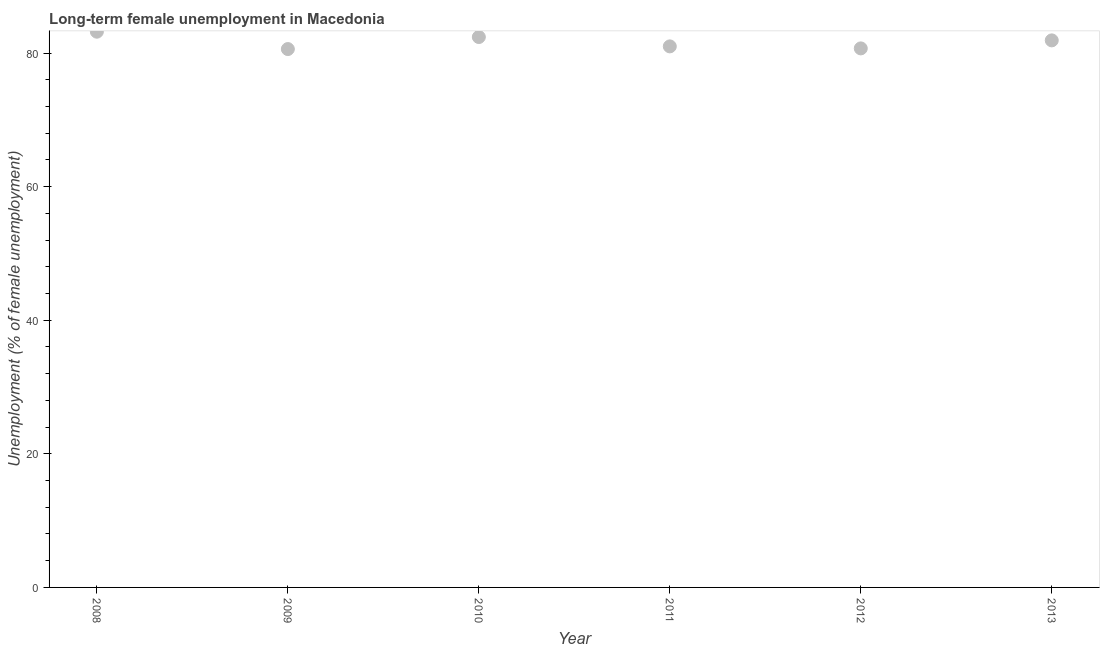What is the long-term female unemployment in 2013?
Ensure brevity in your answer.  81.9. Across all years, what is the maximum long-term female unemployment?
Your answer should be compact. 83.2. Across all years, what is the minimum long-term female unemployment?
Keep it short and to the point. 80.6. In which year was the long-term female unemployment maximum?
Give a very brief answer. 2008. What is the sum of the long-term female unemployment?
Ensure brevity in your answer.  489.8. What is the difference between the long-term female unemployment in 2008 and 2011?
Your answer should be compact. 2.2. What is the average long-term female unemployment per year?
Offer a very short reply. 81.63. What is the median long-term female unemployment?
Offer a terse response. 81.45. In how many years, is the long-term female unemployment greater than 40 %?
Provide a succinct answer. 6. What is the ratio of the long-term female unemployment in 2010 to that in 2012?
Provide a succinct answer. 1.02. Is the long-term female unemployment in 2008 less than that in 2009?
Provide a short and direct response. No. Is the difference between the long-term female unemployment in 2008 and 2010 greater than the difference between any two years?
Your answer should be very brief. No. What is the difference between the highest and the second highest long-term female unemployment?
Provide a short and direct response. 0.8. Is the sum of the long-term female unemployment in 2009 and 2011 greater than the maximum long-term female unemployment across all years?
Your answer should be very brief. Yes. What is the difference between the highest and the lowest long-term female unemployment?
Offer a terse response. 2.6. In how many years, is the long-term female unemployment greater than the average long-term female unemployment taken over all years?
Your answer should be compact. 3. Does the long-term female unemployment monotonically increase over the years?
Your response must be concise. No. How many dotlines are there?
Provide a short and direct response. 1. How many years are there in the graph?
Make the answer very short. 6. What is the difference between two consecutive major ticks on the Y-axis?
Your answer should be very brief. 20. Are the values on the major ticks of Y-axis written in scientific E-notation?
Keep it short and to the point. No. What is the title of the graph?
Give a very brief answer. Long-term female unemployment in Macedonia. What is the label or title of the Y-axis?
Offer a terse response. Unemployment (% of female unemployment). What is the Unemployment (% of female unemployment) in 2008?
Your answer should be compact. 83.2. What is the Unemployment (% of female unemployment) in 2009?
Your response must be concise. 80.6. What is the Unemployment (% of female unemployment) in 2010?
Provide a succinct answer. 82.4. What is the Unemployment (% of female unemployment) in 2012?
Give a very brief answer. 80.7. What is the Unemployment (% of female unemployment) in 2013?
Ensure brevity in your answer.  81.9. What is the difference between the Unemployment (% of female unemployment) in 2008 and 2009?
Your answer should be very brief. 2.6. What is the difference between the Unemployment (% of female unemployment) in 2008 and 2010?
Offer a very short reply. 0.8. What is the difference between the Unemployment (% of female unemployment) in 2008 and 2011?
Offer a very short reply. 2.2. What is the difference between the Unemployment (% of female unemployment) in 2008 and 2013?
Your response must be concise. 1.3. What is the difference between the Unemployment (% of female unemployment) in 2009 and 2010?
Your answer should be compact. -1.8. What is the difference between the Unemployment (% of female unemployment) in 2009 and 2012?
Your response must be concise. -0.1. What is the difference between the Unemployment (% of female unemployment) in 2009 and 2013?
Provide a short and direct response. -1.3. What is the difference between the Unemployment (% of female unemployment) in 2010 and 2012?
Make the answer very short. 1.7. What is the difference between the Unemployment (% of female unemployment) in 2010 and 2013?
Make the answer very short. 0.5. What is the difference between the Unemployment (% of female unemployment) in 2011 and 2012?
Keep it short and to the point. 0.3. What is the difference between the Unemployment (% of female unemployment) in 2011 and 2013?
Offer a terse response. -0.9. What is the difference between the Unemployment (% of female unemployment) in 2012 and 2013?
Your response must be concise. -1.2. What is the ratio of the Unemployment (% of female unemployment) in 2008 to that in 2009?
Offer a very short reply. 1.03. What is the ratio of the Unemployment (% of female unemployment) in 2008 to that in 2011?
Provide a short and direct response. 1.03. What is the ratio of the Unemployment (% of female unemployment) in 2008 to that in 2012?
Ensure brevity in your answer.  1.03. What is the ratio of the Unemployment (% of female unemployment) in 2009 to that in 2010?
Provide a succinct answer. 0.98. What is the ratio of the Unemployment (% of female unemployment) in 2009 to that in 2012?
Ensure brevity in your answer.  1. What is the ratio of the Unemployment (% of female unemployment) in 2010 to that in 2011?
Your answer should be very brief. 1.02. What is the ratio of the Unemployment (% of female unemployment) in 2010 to that in 2013?
Provide a succinct answer. 1.01. What is the ratio of the Unemployment (% of female unemployment) in 2011 to that in 2013?
Offer a very short reply. 0.99. What is the ratio of the Unemployment (% of female unemployment) in 2012 to that in 2013?
Your answer should be very brief. 0.98. 